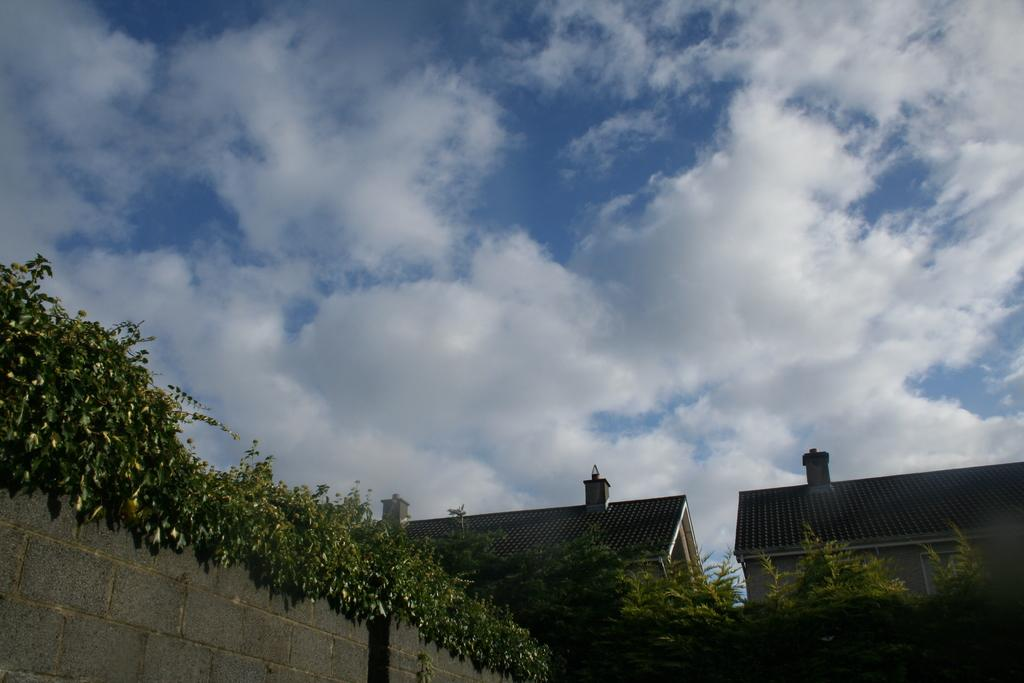What type of natural elements can be seen in the image? There are trees in the image. What man-made structures are visible in the image? There is a wall and buildings in the image. What can be seen in the sky in the image? There are clouds in the image. What part of the sky is visible in the image? The sky is visible in the image. How many units of addition are being performed by the women in the image? There are no women or units of addition present in the image. What type of women can be seen in the image? There are no women present in the image. 